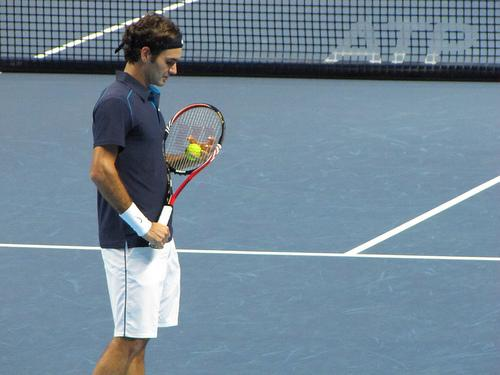List all the objects that have a relation to the sport of tennis in the image. Tennis racket, tennis ball, tennis net, tennis court, painted lines, the man's attire (shirt, shorts, wristband, headband), and the man playing tennis. Mention the type of court and the dominant color in the tennis net. It is a tennis court with a black net. Enumerate the number of objects that make up the man's attire. Six objects: a blue shirt, white shorts, a white wristband, a headband, and a pair of white shoes (not visible but assumed). Mention the general theme and sentiment of the image. The theme is a sporty atmosphere, showcasing a man playing tennis on a court. The sentiment is positive and energetic. Describe the position and color of the lines on the tennis court. The white lines divide the court and are located at different distances from the black net. How many objects are in direct contact with the man's right hand? Two objects: the tennis racket and the tennis ball. Identify the primary colors present in the tennis player's outfit. Blue, white, and a small amount of light blue. Briefly assess the quality of the image based on the level of detail provided in the description. The image quality appears to be high, as there are numerous details and objects described with precise coordinates and dimensions. Elaborate on the interaction between the man and his tennis racket. The man is holding the tennis racket with his right hand, positioning it to hit the tennis ball also held in his hand. What is unique about the man's wristband? The wristband is white with a small design. Is the tennis player's racket green and blue? The tennis racket is described as being black, red, and white, not green and blue. Does the man have a purple headband? The headband in the image is described as black with a white design on the front, not purple. Are the tennis shorts pink with yellow stripes? The man's tennis shorts are described as being white with a thin stripe, not pink with yellow stripes. Is the tennis ball in the air above the court? The tennis ball is described as being in the man's hand, not in the air above the court. Are the lines on the tennis court red and wavy? The lines on the tennis court are described as being white and straight, not red and wavy. Is the tennis court's net yellow with large holes? The tennis net is described as being black, not yellow, and there is no information given about large holes in the net. 